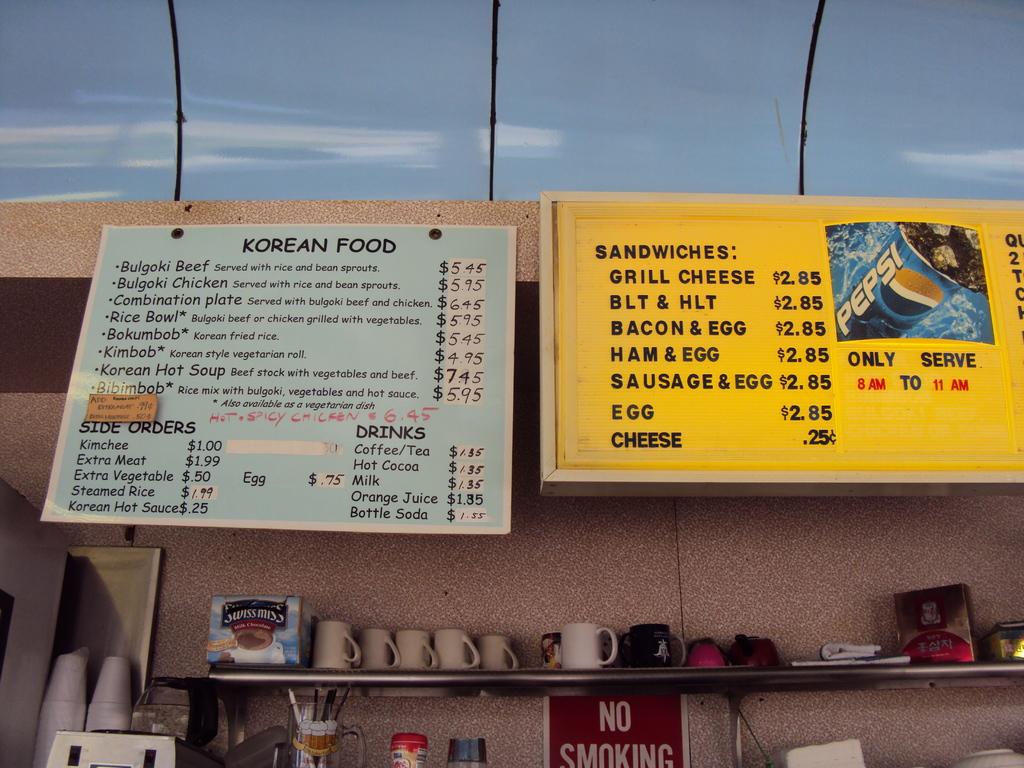What type of ethnic food is on the left?
Ensure brevity in your answer.  Korean. What kind of sandwiches do they have?
Give a very brief answer. Grill cheese. 